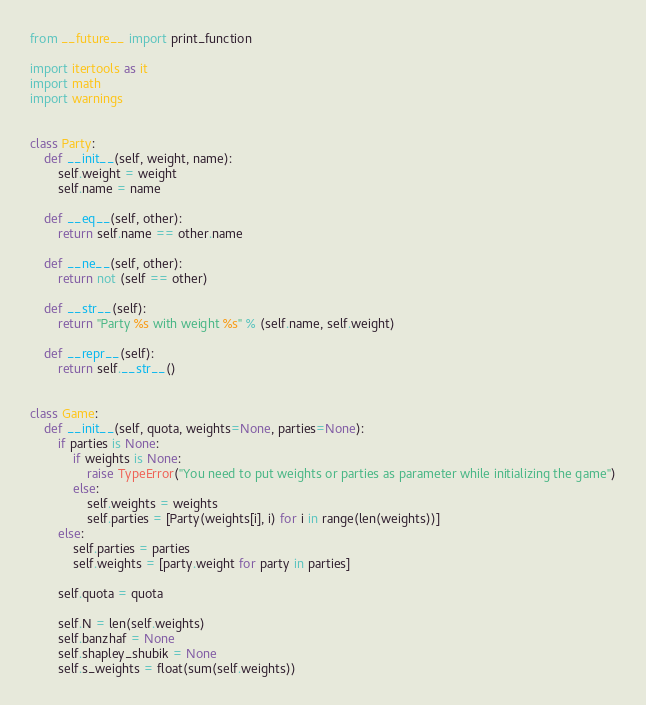<code> <loc_0><loc_0><loc_500><loc_500><_Python_>from __future__ import print_function

import itertools as it
import math
import warnings


class Party:
    def __init__(self, weight, name):
        self.weight = weight
        self.name = name

    def __eq__(self, other):
        return self.name == other.name

    def __ne__(self, other):
        return not (self == other)

    def __str__(self):
        return "Party %s with weight %s" % (self.name, self.weight)

    def __repr__(self):
        return self.__str__()


class Game:
    def __init__(self, quota, weights=None, parties=None):
        if parties is None:
            if weights is None:
                raise TypeError("You need to put weights or parties as parameter while initializing the game")
            else:
                self.weights = weights
                self.parties = [Party(weights[i], i) for i in range(len(weights))]
        else:
            self.parties = parties
            self.weights = [party.weight for party in parties]

        self.quota = quota

        self.N = len(self.weights)
        self.banzhaf = None
        self.shapley_shubik = None
        self.s_weights = float(sum(self.weights))</code> 